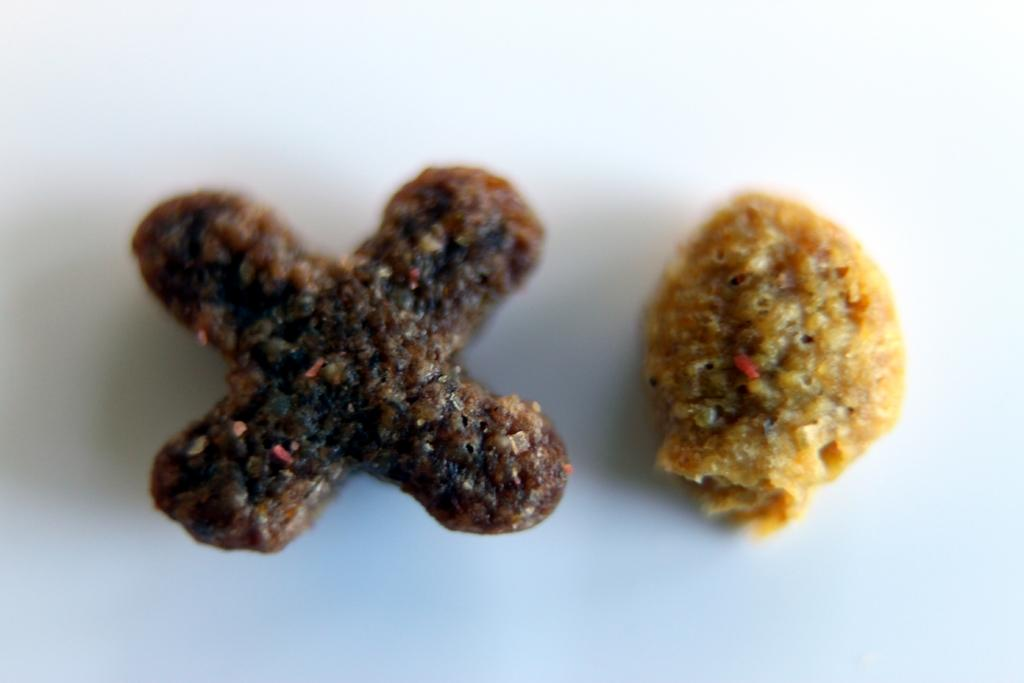What type of food is visible in the image? There are two crispy chips in the image. Where are the crispy chips located? The crispy chips are in a plate. What type of vacation is being planned in the image? There is no indication of a vacation being planned in the image; it only features two crispy chips in a plate. 